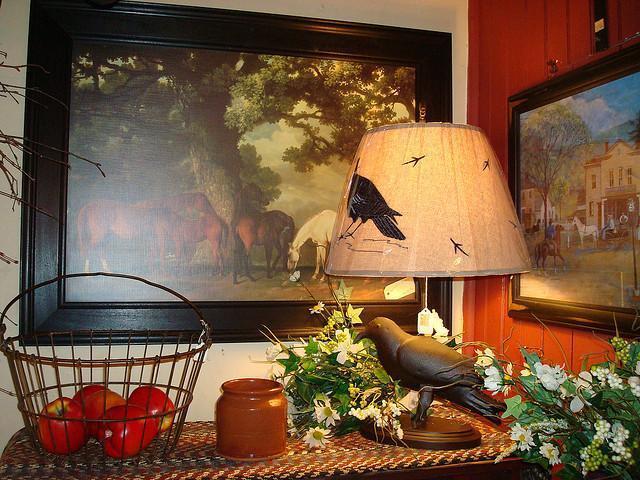How many pictures are in the picture?
Give a very brief answer. 2. How many birds are visible?
Give a very brief answer. 2. 